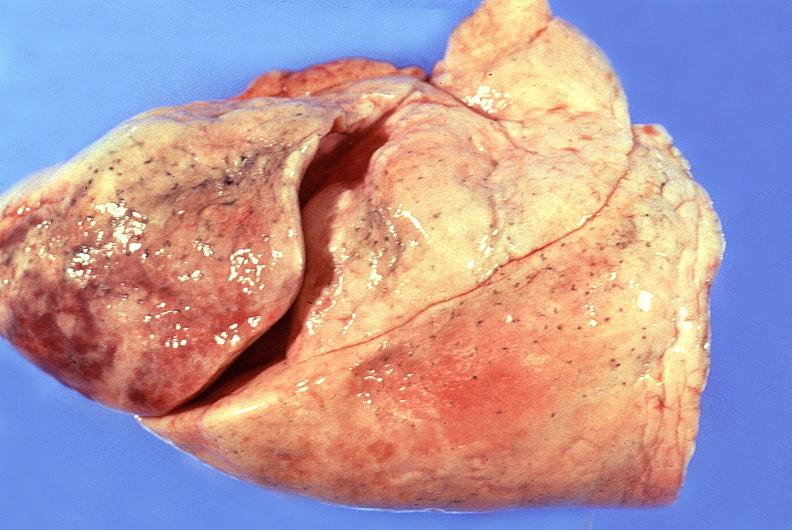what does this image show?
Answer the question using a single word or phrase. Normal lung 